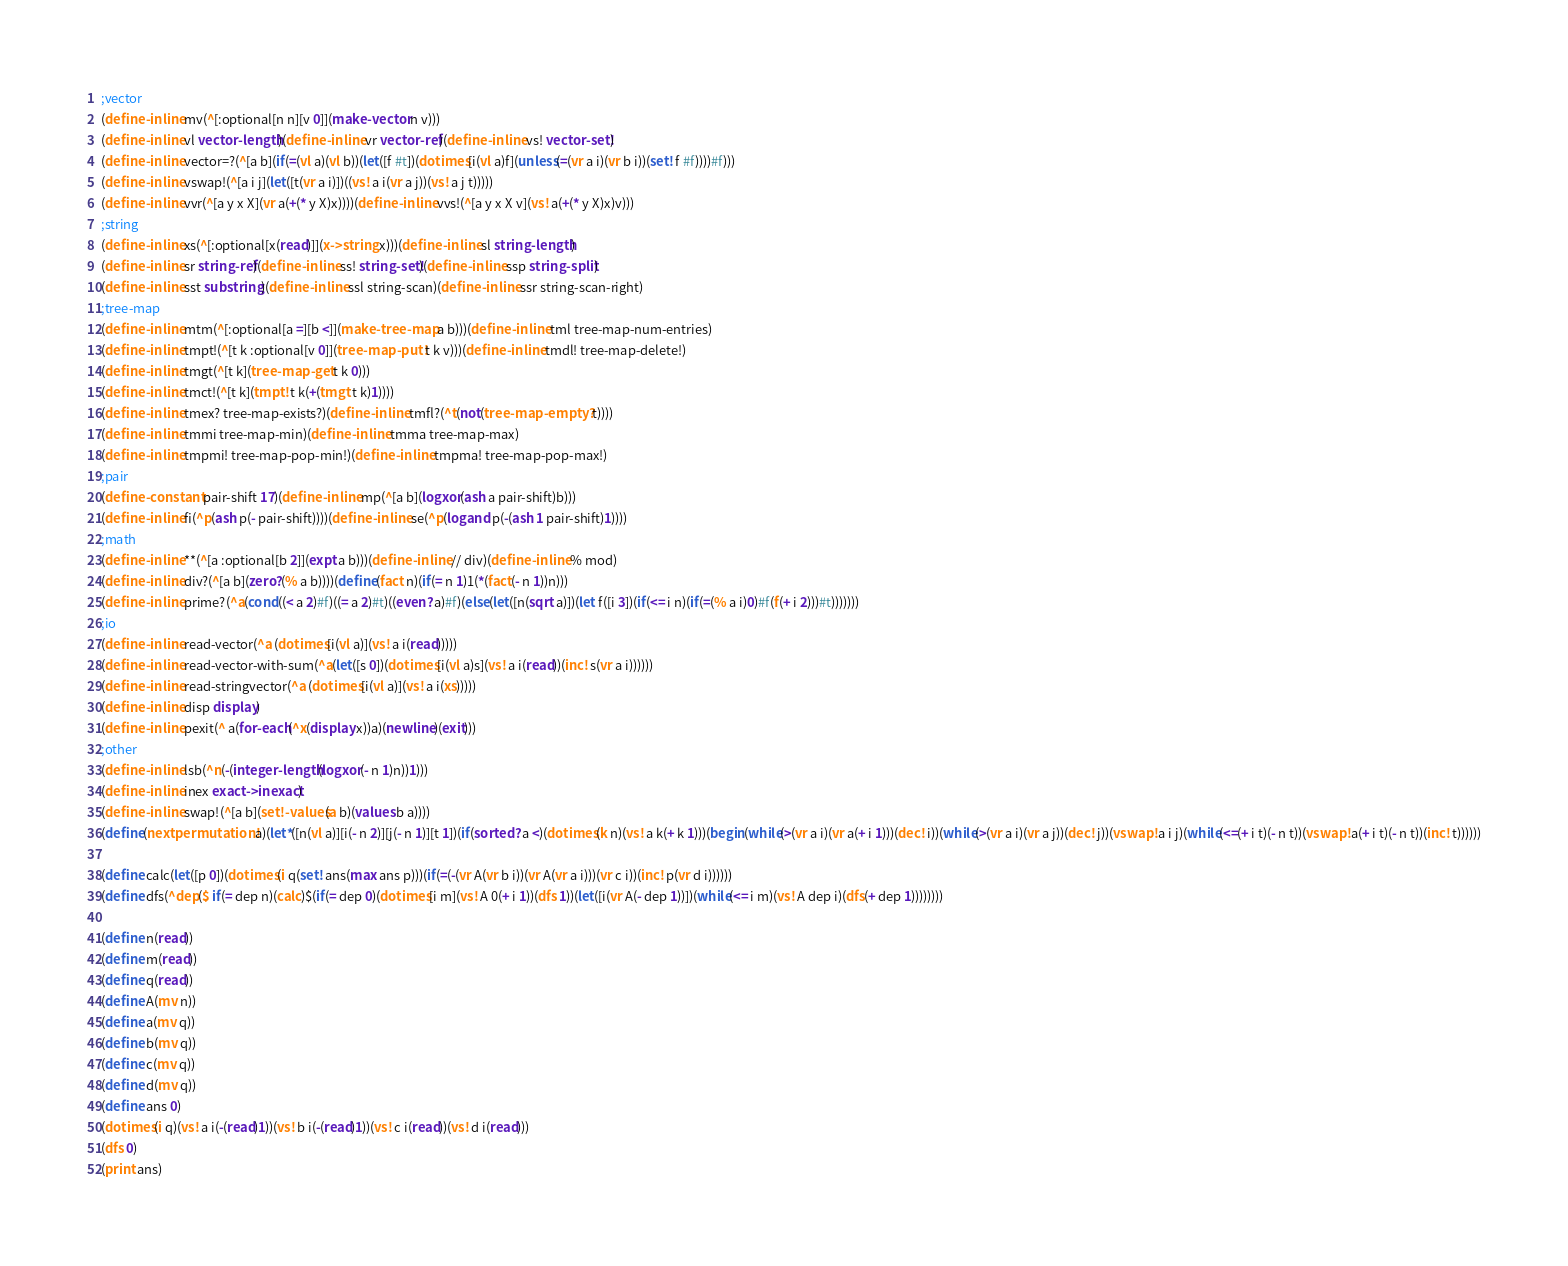<code> <loc_0><loc_0><loc_500><loc_500><_Scheme_>;vector
(define-inline mv(^[:optional[n n][v 0]](make-vector n v)))
(define-inline vl vector-length)(define-inline vr vector-ref)(define-inline vs! vector-set!)
(define-inline vector=?(^[a b](if(=(vl a)(vl b))(let([f #t])(dotimes[i(vl a)f](unless(=(vr a i)(vr b i))(set! f #f))))#f)))
(define-inline vswap!(^[a i j](let([t(vr a i)])((vs! a i(vr a j))(vs! a j t)))))
(define-inline vvr(^[a y x X](vr a(+(* y X)x))))(define-inline vvs!(^[a y x X v](vs! a(+(* y X)x)v)))
;string
(define-inline xs(^[:optional[x(read)]](x->string x)))(define-inline sl string-length)
(define-inline sr string-ref)(define-inline ss! string-set!)(define-inline ssp string-split)
(define-inline sst substring)(define-inline ssl string-scan)(define-inline ssr string-scan-right)
;tree-map
(define-inline mtm(^[:optional[a =][b <]](make-tree-map a b)))(define-inline tml tree-map-num-entries)
(define-inline tmpt!(^[t k :optional[v 0]](tree-map-put! t k v)))(define-inline tmdl! tree-map-delete!)
(define-inline tmgt(^[t k](tree-map-get t k 0)))
(define-inline tmct!(^[t k](tmpt! t k(+(tmgt t k)1))))
(define-inline tmex? tree-map-exists?)(define-inline tmfl?(^t(not(tree-map-empty? t))))
(define-inline tmmi tree-map-min)(define-inline tmma tree-map-max)
(define-inline tmpmi! tree-map-pop-min!)(define-inline tmpma! tree-map-pop-max!)
;pair
(define-constant pair-shift 17)(define-inline mp(^[a b](logxor(ash a pair-shift)b)))
(define-inline fi(^p(ash p(- pair-shift))))(define-inline se(^p(logand p(-(ash 1 pair-shift)1))))
;math
(define-inline **(^[a :optional[b 2]](expt a b)))(define-inline // div)(define-inline % mod)
(define-inline div?(^[a b](zero?(% a b))))(define(fact n)(if(= n 1)1(*(fact(- n 1))n)))
(define-inline prime?(^a(cond((< a 2)#f)((= a 2)#t)((even? a)#f)(else(let([n(sqrt a)])(let f([i 3])(if(<= i n)(if(=(% a i)0)#f(f(+ i 2)))#t)))))))
;io
(define-inline read-vector(^a (dotimes[i(vl a)](vs! a i(read)))))
(define-inline read-vector-with-sum(^a(let([s 0])(dotimes[i(vl a)s](vs! a i(read))(inc! s(vr a i))))))
(define-inline read-stringvector(^a (dotimes[i(vl a)](vs! a i(xs)))))
(define-inline disp display)
(define-inline pexit(^ a(for-each(^x(display x))a)(newline)(exit)))
;other
(define-inline lsb(^n(-(integer-length(logxor(- n 1)n))1)))
(define-inline inex exact->inexact)
(define-inline swap!(^[a b](set!-values(a b)(values b a))))
(define(nextpermutation! a)(let*([n(vl a)][i(- n 2)][j(- n 1)][t 1])(if(sorted? a <)(dotimes(k n)(vs! a k(+ k 1)))(begin(while(>(vr a i)(vr a(+ i 1)))(dec! i))(while(>(vr a i)(vr a j))(dec! j))(vswap! a i j)(while(<=(+ i t)(- n t))(vswap! a(+ i t)(- n t))(inc! t))))))

(define calc(let([p 0])(dotimes(i q(set! ans(max ans p)))(if(=(-(vr A(vr b i))(vr A(vr a i)))(vr c i))(inc! p(vr d i))))))
(define dfs(^dep($ if(= dep n)(calc)$(if(= dep 0)(dotimes[i m](vs! A 0(+ i 1))(dfs 1))(let([i(vr A(- dep 1))])(while(<= i m)(vs! A dep i)(dfs(+ dep 1))))))))

(define n(read))
(define m(read))
(define q(read))
(define A(mv n))
(define a(mv q))
(define b(mv q))
(define c(mv q))
(define d(mv q))
(define ans 0)
(dotimes(i q)(vs! a i(-(read)1))(vs! b i(-(read)1))(vs! c i(read))(vs! d i(read)))
(dfs 0)
(print ans)
</code> 